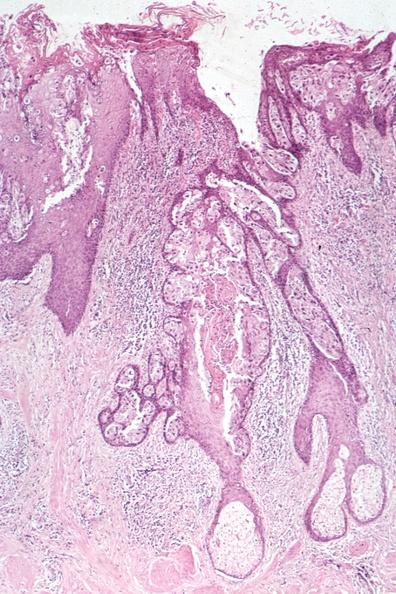s breast present?
Answer the question using a single word or phrase. Yes 